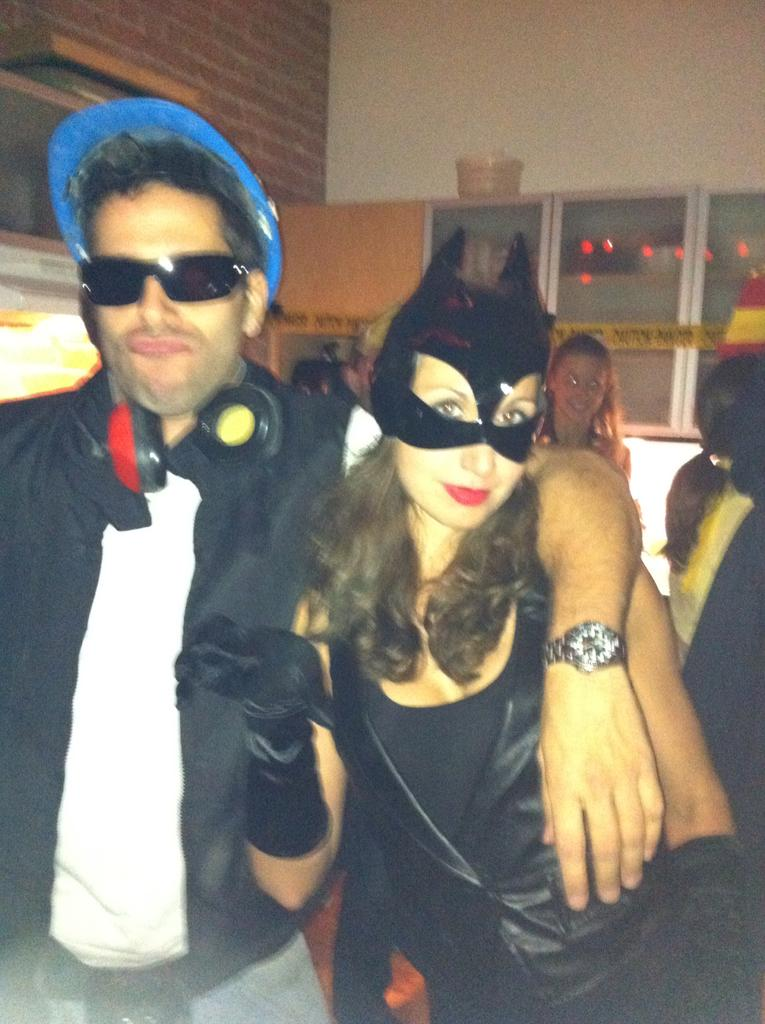How many people are in the image? There are people in the image, but the exact number is not specified. What type of protective gear is visible in the image? There is a cap, goggles, a headset, and a face mask visible in the image. What type of furniture is present in the image? There are cupboards in the image. What else can be seen in the image besides the people and protective gear? There are some unspecified objects in the image. What is the background of the image composed of? The background of the image includes walls. How many planes can be seen flying through the rainstorm in the image? There is no rainstorm or planes present in the image. What happens when someone sneezes in the image? There is no indication of anyone sneezing in the image. 